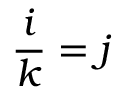Convert formula to latex. <formula><loc_0><loc_0><loc_500><loc_500>{ \frac { i } { k } } = j</formula> 